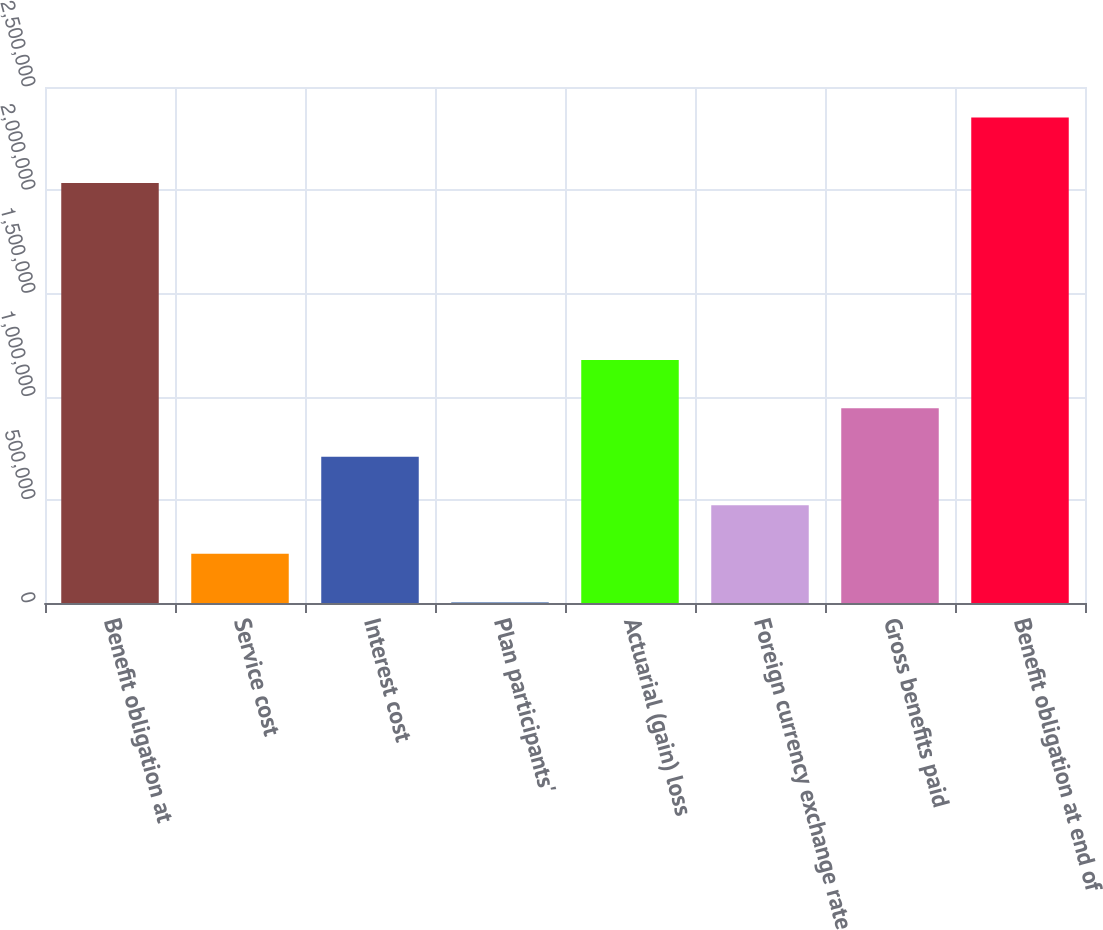Convert chart. <chart><loc_0><loc_0><loc_500><loc_500><bar_chart><fcel>Benefit obligation at<fcel>Service cost<fcel>Interest cost<fcel>Plan participants'<fcel>Actuarial (gain) loss<fcel>Foreign currency exchange rate<fcel>Gross benefits paid<fcel>Benefit obligation at end of<nl><fcel>2.03518e+06<fcel>238383<fcel>708096<fcel>3526<fcel>1.17781e+06<fcel>473240<fcel>942953<fcel>2.35209e+06<nl></chart> 